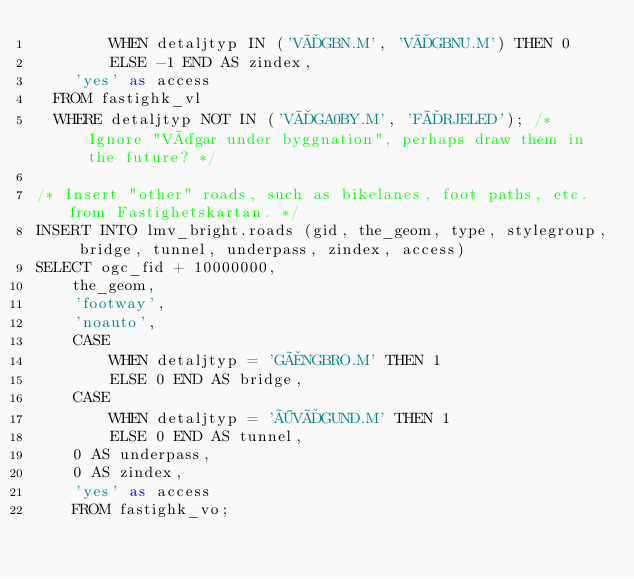Convert code to text. <code><loc_0><loc_0><loc_500><loc_500><_SQL_>        WHEN detaljtyp IN ('VÄGBN.M', 'VÄGBNU.M') THEN 0
        ELSE -1 END AS zindex,
    'yes' as access
  FROM fastighk_vl
  WHERE detaljtyp NOT IN ('VÄGA0BY.M', 'FÄRJELED'); /* Ignore "Vägar under byggnation", perhaps draw them in the future? */

/* Insert "other" roads, such as bikelanes, foot paths, etc. from Fastighetskartan. */
INSERT INTO lmv_bright.roads (gid, the_geom, type, stylegroup, bridge, tunnel, underpass, zindex, access)
SELECT ogc_fid + 10000000,
    the_geom,
    'footway',
    'noauto',
    CASE
        WHEN detaljtyp = 'GÅNGBRO.M' THEN 1
        ELSE 0 END AS bridge,
    CASE
        WHEN detaljtyp = 'ÖVÄGUND.M' THEN 1
        ELSE 0 END AS tunnel,
    0 AS underpass,
    0 AS zindex,
    'yes' as access
    FROM fastighk_vo;
</code> 